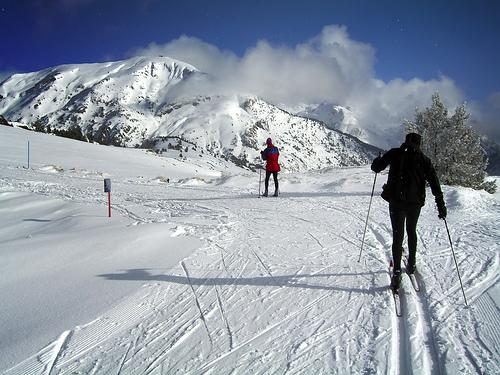Question: where is the tree?
Choices:
A. On the left.
B. In front.
C. On the right.
D. In back.
Answer with the letter. Answer: C Question: where are the ski poles?
Choices:
A. On the ground.
B. In the store.
C. On the skier's feet.
D. In the skiers hands.
Answer with the letter. Answer: D Question: how many skiers are on the snow?
Choices:
A. 3.
B. 4.
C. 5.
D. 2.
Answer with the letter. Answer: D Question: where are the tracks?
Choices:
A. In the snow.
B. In the dirt.
C. In the sand.
D. In cement.
Answer with the letter. Answer: A 